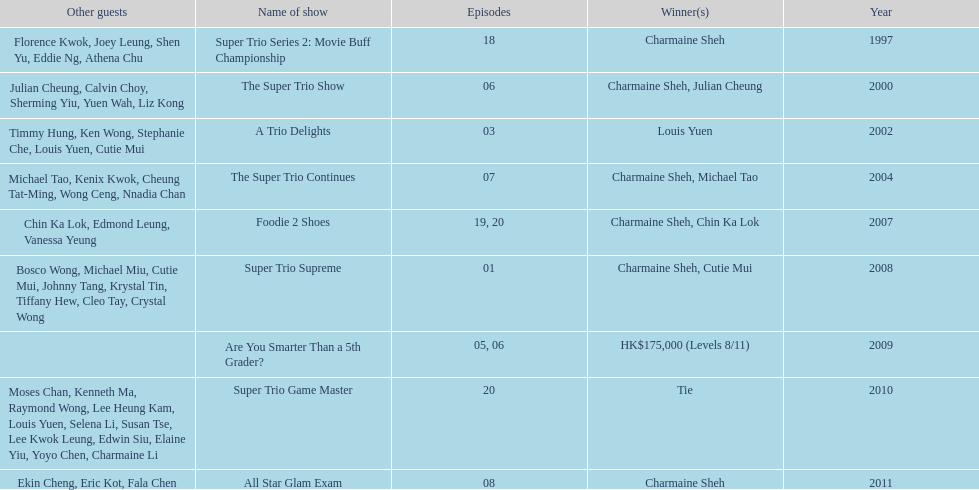How many times has charmaine sheh won on a variety show? 6. 